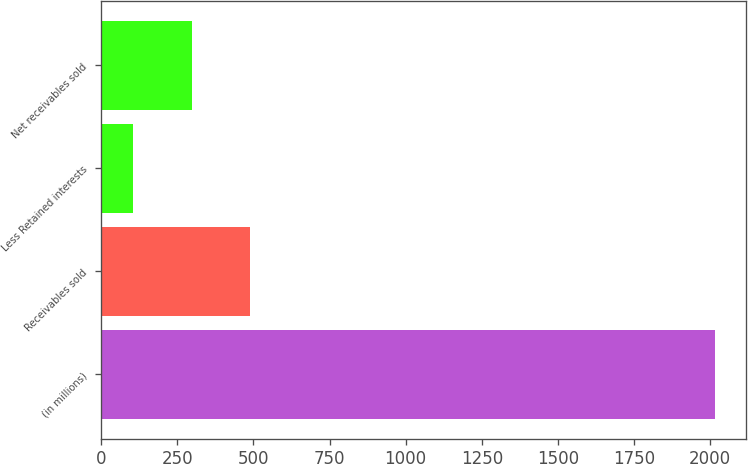Convert chart to OTSL. <chart><loc_0><loc_0><loc_500><loc_500><bar_chart><fcel>(in millions)<fcel>Receivables sold<fcel>Less Retained interests<fcel>Net receivables sold<nl><fcel>2017<fcel>488.2<fcel>106<fcel>297.1<nl></chart> 